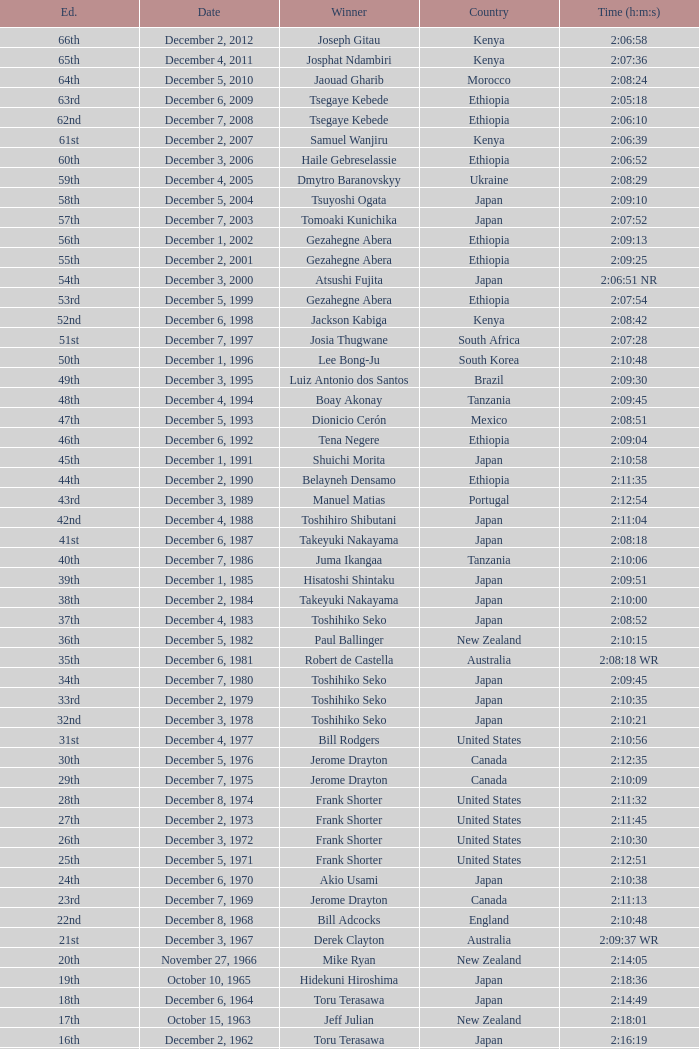Parse the full table. {'header': ['Ed.', 'Date', 'Winner', 'Country', 'Time (h:m:s)'], 'rows': [['66th', 'December 2, 2012', 'Joseph Gitau', 'Kenya', '2:06:58'], ['65th', 'December 4, 2011', 'Josphat Ndambiri', 'Kenya', '2:07:36'], ['64th', 'December 5, 2010', 'Jaouad Gharib', 'Morocco', '2:08:24'], ['63rd', 'December 6, 2009', 'Tsegaye Kebede', 'Ethiopia', '2:05:18'], ['62nd', 'December 7, 2008', 'Tsegaye Kebede', 'Ethiopia', '2:06:10'], ['61st', 'December 2, 2007', 'Samuel Wanjiru', 'Kenya', '2:06:39'], ['60th', 'December 3, 2006', 'Haile Gebreselassie', 'Ethiopia', '2:06:52'], ['59th', 'December 4, 2005', 'Dmytro Baranovskyy', 'Ukraine', '2:08:29'], ['58th', 'December 5, 2004', 'Tsuyoshi Ogata', 'Japan', '2:09:10'], ['57th', 'December 7, 2003', 'Tomoaki Kunichika', 'Japan', '2:07:52'], ['56th', 'December 1, 2002', 'Gezahegne Abera', 'Ethiopia', '2:09:13'], ['55th', 'December 2, 2001', 'Gezahegne Abera', 'Ethiopia', '2:09:25'], ['54th', 'December 3, 2000', 'Atsushi Fujita', 'Japan', '2:06:51 NR'], ['53rd', 'December 5, 1999', 'Gezahegne Abera', 'Ethiopia', '2:07:54'], ['52nd', 'December 6, 1998', 'Jackson Kabiga', 'Kenya', '2:08:42'], ['51st', 'December 7, 1997', 'Josia Thugwane', 'South Africa', '2:07:28'], ['50th', 'December 1, 1996', 'Lee Bong-Ju', 'South Korea', '2:10:48'], ['49th', 'December 3, 1995', 'Luiz Antonio dos Santos', 'Brazil', '2:09:30'], ['48th', 'December 4, 1994', 'Boay Akonay', 'Tanzania', '2:09:45'], ['47th', 'December 5, 1993', 'Dionicio Cerón', 'Mexico', '2:08:51'], ['46th', 'December 6, 1992', 'Tena Negere', 'Ethiopia', '2:09:04'], ['45th', 'December 1, 1991', 'Shuichi Morita', 'Japan', '2:10:58'], ['44th', 'December 2, 1990', 'Belayneh Densamo', 'Ethiopia', '2:11:35'], ['43rd', 'December 3, 1989', 'Manuel Matias', 'Portugal', '2:12:54'], ['42nd', 'December 4, 1988', 'Toshihiro Shibutani', 'Japan', '2:11:04'], ['41st', 'December 6, 1987', 'Takeyuki Nakayama', 'Japan', '2:08:18'], ['40th', 'December 7, 1986', 'Juma Ikangaa', 'Tanzania', '2:10:06'], ['39th', 'December 1, 1985', 'Hisatoshi Shintaku', 'Japan', '2:09:51'], ['38th', 'December 2, 1984', 'Takeyuki Nakayama', 'Japan', '2:10:00'], ['37th', 'December 4, 1983', 'Toshihiko Seko', 'Japan', '2:08:52'], ['36th', 'December 5, 1982', 'Paul Ballinger', 'New Zealand', '2:10:15'], ['35th', 'December 6, 1981', 'Robert de Castella', 'Australia', '2:08:18 WR'], ['34th', 'December 7, 1980', 'Toshihiko Seko', 'Japan', '2:09:45'], ['33rd', 'December 2, 1979', 'Toshihiko Seko', 'Japan', '2:10:35'], ['32nd', 'December 3, 1978', 'Toshihiko Seko', 'Japan', '2:10:21'], ['31st', 'December 4, 1977', 'Bill Rodgers', 'United States', '2:10:56'], ['30th', 'December 5, 1976', 'Jerome Drayton', 'Canada', '2:12:35'], ['29th', 'December 7, 1975', 'Jerome Drayton', 'Canada', '2:10:09'], ['28th', 'December 8, 1974', 'Frank Shorter', 'United States', '2:11:32'], ['27th', 'December 2, 1973', 'Frank Shorter', 'United States', '2:11:45'], ['26th', 'December 3, 1972', 'Frank Shorter', 'United States', '2:10:30'], ['25th', 'December 5, 1971', 'Frank Shorter', 'United States', '2:12:51'], ['24th', 'December 6, 1970', 'Akio Usami', 'Japan', '2:10:38'], ['23rd', 'December 7, 1969', 'Jerome Drayton', 'Canada', '2:11:13'], ['22nd', 'December 8, 1968', 'Bill Adcocks', 'England', '2:10:48'], ['21st', 'December 3, 1967', 'Derek Clayton', 'Australia', '2:09:37 WR'], ['20th', 'November 27, 1966', 'Mike Ryan', 'New Zealand', '2:14:05'], ['19th', 'October 10, 1965', 'Hidekuni Hiroshima', 'Japan', '2:18:36'], ['18th', 'December 6, 1964', 'Toru Terasawa', 'Japan', '2:14:49'], ['17th', 'October 15, 1963', 'Jeff Julian', 'New Zealand', '2:18:01'], ['16th', 'December 2, 1962', 'Toru Terasawa', 'Japan', '2:16:19'], ['15th', 'December 3, 1961', 'Pavel Kantorek', 'Czech Republic', '2:22:05'], ['14th', 'December 4, 1960', 'Barry Magee', 'New Zealand', '2:19:04'], ['13th', 'November 8, 1959', 'Kurao Hiroshima', 'Japan', '2:29:34'], ['12th', 'December 7, 1958', 'Nobuyoshi Sadanaga', 'Japan', '2:24:01'], ['11th', 'December 1, 1957', 'Kurao Hiroshima', 'Japan', '2:21:40'], ['10th', 'December 9, 1956', 'Keizo Yamada', 'Japan', '2:25:15'], ['9th', 'December 11, 1955', 'Veikko Karvonen', 'Finland', '2:23:16'], ['8th', 'December 5, 1954', 'Reinaldo Gorno', 'Argentina', '2:24:55'], ['7th', 'December 6, 1953', 'Hideo Hamamura', 'Japan', '2:27:26'], ['6th', 'December 7, 1952', 'Katsuo Nishida', 'Japan', '2:27:59'], ['5th', 'December 9, 1951', 'Hiromi Haigo', 'Japan', '2:30:13'], ['4th', 'December 10, 1950', 'Shunji Koyanagi', 'Japan', '2:30:47'], ['3rd', 'December 4, 1949', 'Shinzo Koga', 'Japan', '2:40:26'], ['2nd', 'December 5, 1948', 'Saburo Yamada', 'Japan', '2:37:25'], ['1st', 'December 7, 1947', 'Toshikazu Wada', 'Japan', '2:45:45']]} What was the nationality of the winner on December 8, 1968? England. 